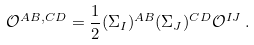Convert formula to latex. <formula><loc_0><loc_0><loc_500><loc_500>\mathcal { O } ^ { A B , C D } = \frac { 1 } { 2 } ( \Sigma _ { I } ) ^ { A B } ( \Sigma _ { J } ) ^ { C D } \mathcal { O } ^ { I J } \, .</formula> 